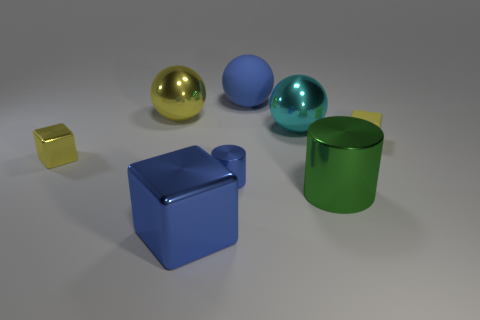Add 1 big gray rubber blocks. How many objects exist? 9 Subtract all cylinders. How many objects are left? 6 Add 3 yellow objects. How many yellow objects exist? 6 Subtract 0 cyan blocks. How many objects are left? 8 Subtract all large cylinders. Subtract all big shiny cylinders. How many objects are left? 6 Add 4 large green metallic things. How many large green metallic things are left? 5 